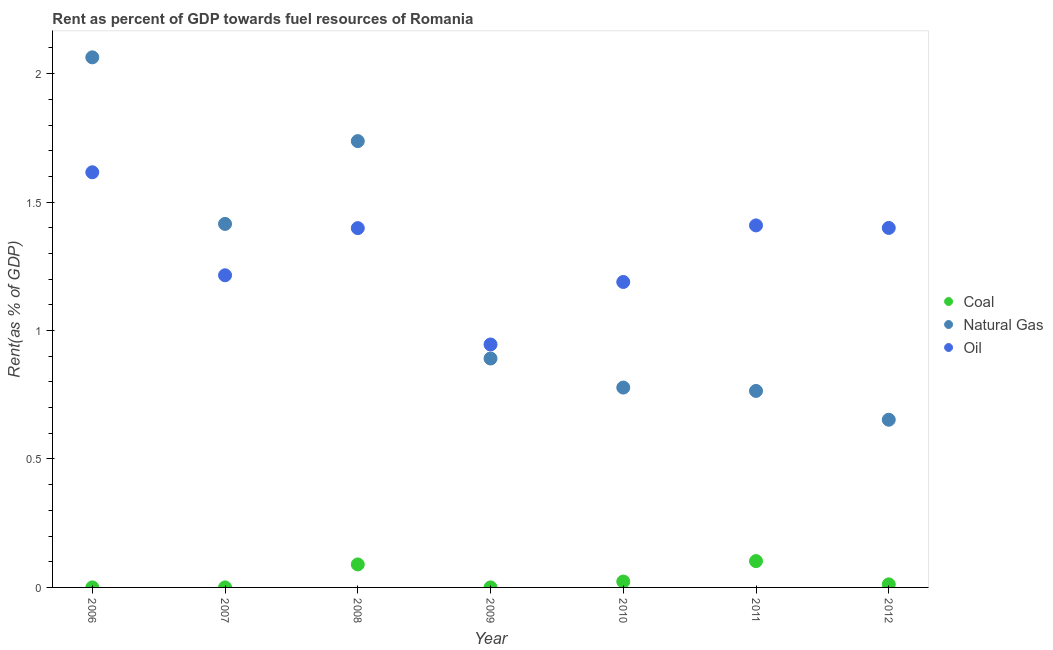How many different coloured dotlines are there?
Make the answer very short. 3. Is the number of dotlines equal to the number of legend labels?
Provide a succinct answer. Yes. What is the rent towards natural gas in 2011?
Provide a succinct answer. 0.76. Across all years, what is the maximum rent towards coal?
Your response must be concise. 0.1. Across all years, what is the minimum rent towards natural gas?
Offer a very short reply. 0.65. In which year was the rent towards oil minimum?
Your response must be concise. 2009. What is the total rent towards coal in the graph?
Your response must be concise. 0.23. What is the difference between the rent towards natural gas in 2008 and that in 2010?
Provide a succinct answer. 0.96. What is the difference between the rent towards natural gas in 2007 and the rent towards coal in 2006?
Keep it short and to the point. 1.41. What is the average rent towards oil per year?
Your answer should be compact. 1.31. In the year 2012, what is the difference between the rent towards coal and rent towards natural gas?
Offer a terse response. -0.64. In how many years, is the rent towards natural gas greater than 1.4 %?
Your response must be concise. 3. What is the ratio of the rent towards oil in 2010 to that in 2011?
Provide a short and direct response. 0.84. What is the difference between the highest and the second highest rent towards natural gas?
Your answer should be very brief. 0.33. What is the difference between the highest and the lowest rent towards oil?
Offer a terse response. 0.67. Is it the case that in every year, the sum of the rent towards coal and rent towards natural gas is greater than the rent towards oil?
Your answer should be very brief. No. Does the rent towards coal monotonically increase over the years?
Provide a short and direct response. No. Is the rent towards oil strictly greater than the rent towards coal over the years?
Keep it short and to the point. Yes. Where does the legend appear in the graph?
Provide a succinct answer. Center right. How many legend labels are there?
Your answer should be very brief. 3. What is the title of the graph?
Offer a terse response. Rent as percent of GDP towards fuel resources of Romania. What is the label or title of the X-axis?
Give a very brief answer. Year. What is the label or title of the Y-axis?
Give a very brief answer. Rent(as % of GDP). What is the Rent(as % of GDP) of Coal in 2006?
Give a very brief answer. 7.42123758365009e-5. What is the Rent(as % of GDP) of Natural Gas in 2006?
Your answer should be compact. 2.06. What is the Rent(as % of GDP) in Oil in 2006?
Keep it short and to the point. 1.62. What is the Rent(as % of GDP) in Coal in 2007?
Offer a terse response. 9.89979329873995e-5. What is the Rent(as % of GDP) of Natural Gas in 2007?
Give a very brief answer. 1.42. What is the Rent(as % of GDP) of Oil in 2007?
Offer a terse response. 1.22. What is the Rent(as % of GDP) in Coal in 2008?
Give a very brief answer. 0.09. What is the Rent(as % of GDP) of Natural Gas in 2008?
Your answer should be compact. 1.74. What is the Rent(as % of GDP) of Oil in 2008?
Offer a very short reply. 1.4. What is the Rent(as % of GDP) in Coal in 2009?
Offer a very short reply. 9.91154234092374e-5. What is the Rent(as % of GDP) in Natural Gas in 2009?
Offer a very short reply. 0.89. What is the Rent(as % of GDP) in Oil in 2009?
Ensure brevity in your answer.  0.95. What is the Rent(as % of GDP) in Coal in 2010?
Ensure brevity in your answer.  0.02. What is the Rent(as % of GDP) in Natural Gas in 2010?
Your answer should be very brief. 0.78. What is the Rent(as % of GDP) of Oil in 2010?
Offer a terse response. 1.19. What is the Rent(as % of GDP) in Coal in 2011?
Offer a very short reply. 0.1. What is the Rent(as % of GDP) of Natural Gas in 2011?
Ensure brevity in your answer.  0.76. What is the Rent(as % of GDP) in Oil in 2011?
Provide a succinct answer. 1.41. What is the Rent(as % of GDP) in Coal in 2012?
Your answer should be very brief. 0.01. What is the Rent(as % of GDP) of Natural Gas in 2012?
Keep it short and to the point. 0.65. What is the Rent(as % of GDP) of Oil in 2012?
Offer a terse response. 1.4. Across all years, what is the maximum Rent(as % of GDP) of Coal?
Provide a succinct answer. 0.1. Across all years, what is the maximum Rent(as % of GDP) of Natural Gas?
Provide a short and direct response. 2.06. Across all years, what is the maximum Rent(as % of GDP) in Oil?
Your response must be concise. 1.62. Across all years, what is the minimum Rent(as % of GDP) in Coal?
Your answer should be compact. 7.42123758365009e-5. Across all years, what is the minimum Rent(as % of GDP) in Natural Gas?
Give a very brief answer. 0.65. Across all years, what is the minimum Rent(as % of GDP) in Oil?
Ensure brevity in your answer.  0.95. What is the total Rent(as % of GDP) of Coal in the graph?
Ensure brevity in your answer.  0.23. What is the total Rent(as % of GDP) of Natural Gas in the graph?
Ensure brevity in your answer.  8.3. What is the total Rent(as % of GDP) in Oil in the graph?
Keep it short and to the point. 9.17. What is the difference between the Rent(as % of GDP) of Coal in 2006 and that in 2007?
Ensure brevity in your answer.  -0. What is the difference between the Rent(as % of GDP) of Natural Gas in 2006 and that in 2007?
Your response must be concise. 0.65. What is the difference between the Rent(as % of GDP) of Oil in 2006 and that in 2007?
Make the answer very short. 0.4. What is the difference between the Rent(as % of GDP) in Coal in 2006 and that in 2008?
Ensure brevity in your answer.  -0.09. What is the difference between the Rent(as % of GDP) of Natural Gas in 2006 and that in 2008?
Offer a very short reply. 0.33. What is the difference between the Rent(as % of GDP) of Oil in 2006 and that in 2008?
Your response must be concise. 0.22. What is the difference between the Rent(as % of GDP) of Natural Gas in 2006 and that in 2009?
Make the answer very short. 1.17. What is the difference between the Rent(as % of GDP) in Oil in 2006 and that in 2009?
Your answer should be very brief. 0.67. What is the difference between the Rent(as % of GDP) in Coal in 2006 and that in 2010?
Keep it short and to the point. -0.02. What is the difference between the Rent(as % of GDP) in Natural Gas in 2006 and that in 2010?
Your response must be concise. 1.29. What is the difference between the Rent(as % of GDP) in Oil in 2006 and that in 2010?
Give a very brief answer. 0.43. What is the difference between the Rent(as % of GDP) of Coal in 2006 and that in 2011?
Your response must be concise. -0.1. What is the difference between the Rent(as % of GDP) in Natural Gas in 2006 and that in 2011?
Provide a short and direct response. 1.3. What is the difference between the Rent(as % of GDP) of Oil in 2006 and that in 2011?
Make the answer very short. 0.21. What is the difference between the Rent(as % of GDP) of Coal in 2006 and that in 2012?
Provide a short and direct response. -0.01. What is the difference between the Rent(as % of GDP) of Natural Gas in 2006 and that in 2012?
Provide a short and direct response. 1.41. What is the difference between the Rent(as % of GDP) in Oil in 2006 and that in 2012?
Give a very brief answer. 0.22. What is the difference between the Rent(as % of GDP) of Coal in 2007 and that in 2008?
Offer a very short reply. -0.09. What is the difference between the Rent(as % of GDP) in Natural Gas in 2007 and that in 2008?
Your answer should be compact. -0.32. What is the difference between the Rent(as % of GDP) of Oil in 2007 and that in 2008?
Your answer should be very brief. -0.18. What is the difference between the Rent(as % of GDP) of Coal in 2007 and that in 2009?
Make the answer very short. -0. What is the difference between the Rent(as % of GDP) of Natural Gas in 2007 and that in 2009?
Ensure brevity in your answer.  0.52. What is the difference between the Rent(as % of GDP) of Oil in 2007 and that in 2009?
Make the answer very short. 0.27. What is the difference between the Rent(as % of GDP) in Coal in 2007 and that in 2010?
Keep it short and to the point. -0.02. What is the difference between the Rent(as % of GDP) in Natural Gas in 2007 and that in 2010?
Offer a terse response. 0.64. What is the difference between the Rent(as % of GDP) in Oil in 2007 and that in 2010?
Make the answer very short. 0.03. What is the difference between the Rent(as % of GDP) of Coal in 2007 and that in 2011?
Provide a short and direct response. -0.1. What is the difference between the Rent(as % of GDP) of Natural Gas in 2007 and that in 2011?
Provide a short and direct response. 0.65. What is the difference between the Rent(as % of GDP) in Oil in 2007 and that in 2011?
Give a very brief answer. -0.19. What is the difference between the Rent(as % of GDP) in Coal in 2007 and that in 2012?
Your answer should be very brief. -0.01. What is the difference between the Rent(as % of GDP) of Natural Gas in 2007 and that in 2012?
Keep it short and to the point. 0.76. What is the difference between the Rent(as % of GDP) of Oil in 2007 and that in 2012?
Ensure brevity in your answer.  -0.18. What is the difference between the Rent(as % of GDP) in Coal in 2008 and that in 2009?
Your response must be concise. 0.09. What is the difference between the Rent(as % of GDP) in Natural Gas in 2008 and that in 2009?
Your answer should be compact. 0.85. What is the difference between the Rent(as % of GDP) of Oil in 2008 and that in 2009?
Offer a terse response. 0.45. What is the difference between the Rent(as % of GDP) in Coal in 2008 and that in 2010?
Your answer should be compact. 0.07. What is the difference between the Rent(as % of GDP) in Natural Gas in 2008 and that in 2010?
Provide a succinct answer. 0.96. What is the difference between the Rent(as % of GDP) of Oil in 2008 and that in 2010?
Your answer should be very brief. 0.21. What is the difference between the Rent(as % of GDP) in Coal in 2008 and that in 2011?
Your answer should be very brief. -0.01. What is the difference between the Rent(as % of GDP) in Natural Gas in 2008 and that in 2011?
Provide a succinct answer. 0.97. What is the difference between the Rent(as % of GDP) in Oil in 2008 and that in 2011?
Offer a terse response. -0.01. What is the difference between the Rent(as % of GDP) of Coal in 2008 and that in 2012?
Provide a short and direct response. 0.08. What is the difference between the Rent(as % of GDP) in Natural Gas in 2008 and that in 2012?
Provide a succinct answer. 1.08. What is the difference between the Rent(as % of GDP) in Oil in 2008 and that in 2012?
Offer a very short reply. -0. What is the difference between the Rent(as % of GDP) of Coal in 2009 and that in 2010?
Provide a succinct answer. -0.02. What is the difference between the Rent(as % of GDP) in Natural Gas in 2009 and that in 2010?
Keep it short and to the point. 0.11. What is the difference between the Rent(as % of GDP) in Oil in 2009 and that in 2010?
Ensure brevity in your answer.  -0.24. What is the difference between the Rent(as % of GDP) in Coal in 2009 and that in 2011?
Your answer should be very brief. -0.1. What is the difference between the Rent(as % of GDP) in Natural Gas in 2009 and that in 2011?
Ensure brevity in your answer.  0.13. What is the difference between the Rent(as % of GDP) of Oil in 2009 and that in 2011?
Ensure brevity in your answer.  -0.46. What is the difference between the Rent(as % of GDP) of Coal in 2009 and that in 2012?
Your answer should be very brief. -0.01. What is the difference between the Rent(as % of GDP) of Natural Gas in 2009 and that in 2012?
Ensure brevity in your answer.  0.24. What is the difference between the Rent(as % of GDP) in Oil in 2009 and that in 2012?
Offer a terse response. -0.45. What is the difference between the Rent(as % of GDP) in Coal in 2010 and that in 2011?
Your response must be concise. -0.08. What is the difference between the Rent(as % of GDP) in Natural Gas in 2010 and that in 2011?
Your answer should be very brief. 0.01. What is the difference between the Rent(as % of GDP) of Oil in 2010 and that in 2011?
Give a very brief answer. -0.22. What is the difference between the Rent(as % of GDP) of Coal in 2010 and that in 2012?
Offer a terse response. 0.01. What is the difference between the Rent(as % of GDP) of Natural Gas in 2010 and that in 2012?
Make the answer very short. 0.13. What is the difference between the Rent(as % of GDP) of Oil in 2010 and that in 2012?
Provide a short and direct response. -0.21. What is the difference between the Rent(as % of GDP) of Coal in 2011 and that in 2012?
Offer a very short reply. 0.09. What is the difference between the Rent(as % of GDP) in Natural Gas in 2011 and that in 2012?
Provide a short and direct response. 0.11. What is the difference between the Rent(as % of GDP) of Oil in 2011 and that in 2012?
Keep it short and to the point. 0.01. What is the difference between the Rent(as % of GDP) in Coal in 2006 and the Rent(as % of GDP) in Natural Gas in 2007?
Make the answer very short. -1.42. What is the difference between the Rent(as % of GDP) in Coal in 2006 and the Rent(as % of GDP) in Oil in 2007?
Ensure brevity in your answer.  -1.22. What is the difference between the Rent(as % of GDP) in Natural Gas in 2006 and the Rent(as % of GDP) in Oil in 2007?
Your answer should be compact. 0.85. What is the difference between the Rent(as % of GDP) of Coal in 2006 and the Rent(as % of GDP) of Natural Gas in 2008?
Your response must be concise. -1.74. What is the difference between the Rent(as % of GDP) of Coal in 2006 and the Rent(as % of GDP) of Oil in 2008?
Make the answer very short. -1.4. What is the difference between the Rent(as % of GDP) in Natural Gas in 2006 and the Rent(as % of GDP) in Oil in 2008?
Offer a terse response. 0.66. What is the difference between the Rent(as % of GDP) in Coal in 2006 and the Rent(as % of GDP) in Natural Gas in 2009?
Give a very brief answer. -0.89. What is the difference between the Rent(as % of GDP) of Coal in 2006 and the Rent(as % of GDP) of Oil in 2009?
Your answer should be compact. -0.95. What is the difference between the Rent(as % of GDP) of Natural Gas in 2006 and the Rent(as % of GDP) of Oil in 2009?
Make the answer very short. 1.12. What is the difference between the Rent(as % of GDP) of Coal in 2006 and the Rent(as % of GDP) of Natural Gas in 2010?
Keep it short and to the point. -0.78. What is the difference between the Rent(as % of GDP) of Coal in 2006 and the Rent(as % of GDP) of Oil in 2010?
Your answer should be compact. -1.19. What is the difference between the Rent(as % of GDP) of Natural Gas in 2006 and the Rent(as % of GDP) of Oil in 2010?
Offer a very short reply. 0.87. What is the difference between the Rent(as % of GDP) in Coal in 2006 and the Rent(as % of GDP) in Natural Gas in 2011?
Ensure brevity in your answer.  -0.76. What is the difference between the Rent(as % of GDP) in Coal in 2006 and the Rent(as % of GDP) in Oil in 2011?
Keep it short and to the point. -1.41. What is the difference between the Rent(as % of GDP) of Natural Gas in 2006 and the Rent(as % of GDP) of Oil in 2011?
Your answer should be very brief. 0.65. What is the difference between the Rent(as % of GDP) in Coal in 2006 and the Rent(as % of GDP) in Natural Gas in 2012?
Provide a succinct answer. -0.65. What is the difference between the Rent(as % of GDP) in Coal in 2006 and the Rent(as % of GDP) in Oil in 2012?
Make the answer very short. -1.4. What is the difference between the Rent(as % of GDP) of Natural Gas in 2006 and the Rent(as % of GDP) of Oil in 2012?
Provide a succinct answer. 0.66. What is the difference between the Rent(as % of GDP) in Coal in 2007 and the Rent(as % of GDP) in Natural Gas in 2008?
Your answer should be compact. -1.74. What is the difference between the Rent(as % of GDP) in Coal in 2007 and the Rent(as % of GDP) in Oil in 2008?
Provide a succinct answer. -1.4. What is the difference between the Rent(as % of GDP) in Natural Gas in 2007 and the Rent(as % of GDP) in Oil in 2008?
Provide a succinct answer. 0.02. What is the difference between the Rent(as % of GDP) in Coal in 2007 and the Rent(as % of GDP) in Natural Gas in 2009?
Give a very brief answer. -0.89. What is the difference between the Rent(as % of GDP) in Coal in 2007 and the Rent(as % of GDP) in Oil in 2009?
Give a very brief answer. -0.95. What is the difference between the Rent(as % of GDP) of Natural Gas in 2007 and the Rent(as % of GDP) of Oil in 2009?
Provide a short and direct response. 0.47. What is the difference between the Rent(as % of GDP) in Coal in 2007 and the Rent(as % of GDP) in Natural Gas in 2010?
Your answer should be compact. -0.78. What is the difference between the Rent(as % of GDP) in Coal in 2007 and the Rent(as % of GDP) in Oil in 2010?
Keep it short and to the point. -1.19. What is the difference between the Rent(as % of GDP) in Natural Gas in 2007 and the Rent(as % of GDP) in Oil in 2010?
Your answer should be very brief. 0.23. What is the difference between the Rent(as % of GDP) in Coal in 2007 and the Rent(as % of GDP) in Natural Gas in 2011?
Provide a succinct answer. -0.76. What is the difference between the Rent(as % of GDP) in Coal in 2007 and the Rent(as % of GDP) in Oil in 2011?
Your response must be concise. -1.41. What is the difference between the Rent(as % of GDP) in Natural Gas in 2007 and the Rent(as % of GDP) in Oil in 2011?
Give a very brief answer. 0.01. What is the difference between the Rent(as % of GDP) in Coal in 2007 and the Rent(as % of GDP) in Natural Gas in 2012?
Your answer should be very brief. -0.65. What is the difference between the Rent(as % of GDP) of Coal in 2007 and the Rent(as % of GDP) of Oil in 2012?
Keep it short and to the point. -1.4. What is the difference between the Rent(as % of GDP) in Natural Gas in 2007 and the Rent(as % of GDP) in Oil in 2012?
Your response must be concise. 0.02. What is the difference between the Rent(as % of GDP) in Coal in 2008 and the Rent(as % of GDP) in Natural Gas in 2009?
Your response must be concise. -0.8. What is the difference between the Rent(as % of GDP) in Coal in 2008 and the Rent(as % of GDP) in Oil in 2009?
Offer a very short reply. -0.86. What is the difference between the Rent(as % of GDP) in Natural Gas in 2008 and the Rent(as % of GDP) in Oil in 2009?
Your response must be concise. 0.79. What is the difference between the Rent(as % of GDP) of Coal in 2008 and the Rent(as % of GDP) of Natural Gas in 2010?
Make the answer very short. -0.69. What is the difference between the Rent(as % of GDP) of Coal in 2008 and the Rent(as % of GDP) of Oil in 2010?
Make the answer very short. -1.1. What is the difference between the Rent(as % of GDP) of Natural Gas in 2008 and the Rent(as % of GDP) of Oil in 2010?
Your answer should be compact. 0.55. What is the difference between the Rent(as % of GDP) in Coal in 2008 and the Rent(as % of GDP) in Natural Gas in 2011?
Provide a short and direct response. -0.68. What is the difference between the Rent(as % of GDP) of Coal in 2008 and the Rent(as % of GDP) of Oil in 2011?
Offer a terse response. -1.32. What is the difference between the Rent(as % of GDP) in Natural Gas in 2008 and the Rent(as % of GDP) in Oil in 2011?
Provide a short and direct response. 0.33. What is the difference between the Rent(as % of GDP) in Coal in 2008 and the Rent(as % of GDP) in Natural Gas in 2012?
Offer a very short reply. -0.56. What is the difference between the Rent(as % of GDP) in Coal in 2008 and the Rent(as % of GDP) in Oil in 2012?
Offer a terse response. -1.31. What is the difference between the Rent(as % of GDP) in Natural Gas in 2008 and the Rent(as % of GDP) in Oil in 2012?
Ensure brevity in your answer.  0.34. What is the difference between the Rent(as % of GDP) of Coal in 2009 and the Rent(as % of GDP) of Natural Gas in 2010?
Keep it short and to the point. -0.78. What is the difference between the Rent(as % of GDP) of Coal in 2009 and the Rent(as % of GDP) of Oil in 2010?
Your response must be concise. -1.19. What is the difference between the Rent(as % of GDP) of Natural Gas in 2009 and the Rent(as % of GDP) of Oil in 2010?
Provide a succinct answer. -0.3. What is the difference between the Rent(as % of GDP) in Coal in 2009 and the Rent(as % of GDP) in Natural Gas in 2011?
Ensure brevity in your answer.  -0.76. What is the difference between the Rent(as % of GDP) of Coal in 2009 and the Rent(as % of GDP) of Oil in 2011?
Make the answer very short. -1.41. What is the difference between the Rent(as % of GDP) of Natural Gas in 2009 and the Rent(as % of GDP) of Oil in 2011?
Your answer should be very brief. -0.52. What is the difference between the Rent(as % of GDP) in Coal in 2009 and the Rent(as % of GDP) in Natural Gas in 2012?
Your answer should be very brief. -0.65. What is the difference between the Rent(as % of GDP) in Coal in 2009 and the Rent(as % of GDP) in Oil in 2012?
Your answer should be compact. -1.4. What is the difference between the Rent(as % of GDP) in Natural Gas in 2009 and the Rent(as % of GDP) in Oil in 2012?
Keep it short and to the point. -0.51. What is the difference between the Rent(as % of GDP) of Coal in 2010 and the Rent(as % of GDP) of Natural Gas in 2011?
Provide a succinct answer. -0.74. What is the difference between the Rent(as % of GDP) of Coal in 2010 and the Rent(as % of GDP) of Oil in 2011?
Your answer should be compact. -1.39. What is the difference between the Rent(as % of GDP) in Natural Gas in 2010 and the Rent(as % of GDP) in Oil in 2011?
Your answer should be very brief. -0.63. What is the difference between the Rent(as % of GDP) of Coal in 2010 and the Rent(as % of GDP) of Natural Gas in 2012?
Provide a succinct answer. -0.63. What is the difference between the Rent(as % of GDP) in Coal in 2010 and the Rent(as % of GDP) in Oil in 2012?
Your answer should be compact. -1.38. What is the difference between the Rent(as % of GDP) of Natural Gas in 2010 and the Rent(as % of GDP) of Oil in 2012?
Keep it short and to the point. -0.62. What is the difference between the Rent(as % of GDP) in Coal in 2011 and the Rent(as % of GDP) in Natural Gas in 2012?
Ensure brevity in your answer.  -0.55. What is the difference between the Rent(as % of GDP) of Coal in 2011 and the Rent(as % of GDP) of Oil in 2012?
Offer a very short reply. -1.3. What is the difference between the Rent(as % of GDP) of Natural Gas in 2011 and the Rent(as % of GDP) of Oil in 2012?
Offer a terse response. -0.63. What is the average Rent(as % of GDP) in Coal per year?
Your response must be concise. 0.03. What is the average Rent(as % of GDP) in Natural Gas per year?
Provide a short and direct response. 1.19. What is the average Rent(as % of GDP) in Oil per year?
Ensure brevity in your answer.  1.31. In the year 2006, what is the difference between the Rent(as % of GDP) of Coal and Rent(as % of GDP) of Natural Gas?
Provide a succinct answer. -2.06. In the year 2006, what is the difference between the Rent(as % of GDP) in Coal and Rent(as % of GDP) in Oil?
Your response must be concise. -1.62. In the year 2006, what is the difference between the Rent(as % of GDP) in Natural Gas and Rent(as % of GDP) in Oil?
Provide a short and direct response. 0.45. In the year 2007, what is the difference between the Rent(as % of GDP) in Coal and Rent(as % of GDP) in Natural Gas?
Provide a short and direct response. -1.42. In the year 2007, what is the difference between the Rent(as % of GDP) in Coal and Rent(as % of GDP) in Oil?
Your response must be concise. -1.22. In the year 2007, what is the difference between the Rent(as % of GDP) in Natural Gas and Rent(as % of GDP) in Oil?
Offer a very short reply. 0.2. In the year 2008, what is the difference between the Rent(as % of GDP) in Coal and Rent(as % of GDP) in Natural Gas?
Your answer should be very brief. -1.65. In the year 2008, what is the difference between the Rent(as % of GDP) of Coal and Rent(as % of GDP) of Oil?
Ensure brevity in your answer.  -1.31. In the year 2008, what is the difference between the Rent(as % of GDP) of Natural Gas and Rent(as % of GDP) of Oil?
Provide a short and direct response. 0.34. In the year 2009, what is the difference between the Rent(as % of GDP) in Coal and Rent(as % of GDP) in Natural Gas?
Give a very brief answer. -0.89. In the year 2009, what is the difference between the Rent(as % of GDP) of Coal and Rent(as % of GDP) of Oil?
Offer a very short reply. -0.95. In the year 2009, what is the difference between the Rent(as % of GDP) of Natural Gas and Rent(as % of GDP) of Oil?
Your response must be concise. -0.05. In the year 2010, what is the difference between the Rent(as % of GDP) of Coal and Rent(as % of GDP) of Natural Gas?
Ensure brevity in your answer.  -0.76. In the year 2010, what is the difference between the Rent(as % of GDP) of Coal and Rent(as % of GDP) of Oil?
Ensure brevity in your answer.  -1.17. In the year 2010, what is the difference between the Rent(as % of GDP) of Natural Gas and Rent(as % of GDP) of Oil?
Your response must be concise. -0.41. In the year 2011, what is the difference between the Rent(as % of GDP) in Coal and Rent(as % of GDP) in Natural Gas?
Keep it short and to the point. -0.66. In the year 2011, what is the difference between the Rent(as % of GDP) of Coal and Rent(as % of GDP) of Oil?
Make the answer very short. -1.31. In the year 2011, what is the difference between the Rent(as % of GDP) of Natural Gas and Rent(as % of GDP) of Oil?
Ensure brevity in your answer.  -0.64. In the year 2012, what is the difference between the Rent(as % of GDP) in Coal and Rent(as % of GDP) in Natural Gas?
Ensure brevity in your answer.  -0.64. In the year 2012, what is the difference between the Rent(as % of GDP) in Coal and Rent(as % of GDP) in Oil?
Give a very brief answer. -1.39. In the year 2012, what is the difference between the Rent(as % of GDP) in Natural Gas and Rent(as % of GDP) in Oil?
Provide a short and direct response. -0.75. What is the ratio of the Rent(as % of GDP) of Coal in 2006 to that in 2007?
Your answer should be very brief. 0.75. What is the ratio of the Rent(as % of GDP) in Natural Gas in 2006 to that in 2007?
Make the answer very short. 1.46. What is the ratio of the Rent(as % of GDP) in Oil in 2006 to that in 2007?
Give a very brief answer. 1.33. What is the ratio of the Rent(as % of GDP) of Coal in 2006 to that in 2008?
Make the answer very short. 0. What is the ratio of the Rent(as % of GDP) of Natural Gas in 2006 to that in 2008?
Offer a terse response. 1.19. What is the ratio of the Rent(as % of GDP) of Oil in 2006 to that in 2008?
Your answer should be compact. 1.16. What is the ratio of the Rent(as % of GDP) in Coal in 2006 to that in 2009?
Provide a succinct answer. 0.75. What is the ratio of the Rent(as % of GDP) in Natural Gas in 2006 to that in 2009?
Your answer should be very brief. 2.32. What is the ratio of the Rent(as % of GDP) in Oil in 2006 to that in 2009?
Your answer should be very brief. 1.71. What is the ratio of the Rent(as % of GDP) in Coal in 2006 to that in 2010?
Provide a short and direct response. 0. What is the ratio of the Rent(as % of GDP) in Natural Gas in 2006 to that in 2010?
Keep it short and to the point. 2.65. What is the ratio of the Rent(as % of GDP) in Oil in 2006 to that in 2010?
Your response must be concise. 1.36. What is the ratio of the Rent(as % of GDP) in Coal in 2006 to that in 2011?
Ensure brevity in your answer.  0. What is the ratio of the Rent(as % of GDP) in Natural Gas in 2006 to that in 2011?
Provide a short and direct response. 2.7. What is the ratio of the Rent(as % of GDP) in Oil in 2006 to that in 2011?
Your answer should be very brief. 1.15. What is the ratio of the Rent(as % of GDP) in Coal in 2006 to that in 2012?
Your response must be concise. 0.01. What is the ratio of the Rent(as % of GDP) in Natural Gas in 2006 to that in 2012?
Your answer should be compact. 3.16. What is the ratio of the Rent(as % of GDP) of Oil in 2006 to that in 2012?
Provide a succinct answer. 1.15. What is the ratio of the Rent(as % of GDP) in Coal in 2007 to that in 2008?
Your response must be concise. 0. What is the ratio of the Rent(as % of GDP) in Natural Gas in 2007 to that in 2008?
Offer a terse response. 0.81. What is the ratio of the Rent(as % of GDP) of Oil in 2007 to that in 2008?
Your answer should be very brief. 0.87. What is the ratio of the Rent(as % of GDP) in Natural Gas in 2007 to that in 2009?
Keep it short and to the point. 1.59. What is the ratio of the Rent(as % of GDP) in Oil in 2007 to that in 2009?
Give a very brief answer. 1.28. What is the ratio of the Rent(as % of GDP) in Coal in 2007 to that in 2010?
Provide a succinct answer. 0. What is the ratio of the Rent(as % of GDP) in Natural Gas in 2007 to that in 2010?
Your answer should be very brief. 1.82. What is the ratio of the Rent(as % of GDP) of Natural Gas in 2007 to that in 2011?
Your response must be concise. 1.85. What is the ratio of the Rent(as % of GDP) of Oil in 2007 to that in 2011?
Your answer should be very brief. 0.86. What is the ratio of the Rent(as % of GDP) of Coal in 2007 to that in 2012?
Your answer should be compact. 0.01. What is the ratio of the Rent(as % of GDP) of Natural Gas in 2007 to that in 2012?
Offer a terse response. 2.17. What is the ratio of the Rent(as % of GDP) of Oil in 2007 to that in 2012?
Make the answer very short. 0.87. What is the ratio of the Rent(as % of GDP) in Coal in 2008 to that in 2009?
Give a very brief answer. 903.21. What is the ratio of the Rent(as % of GDP) of Natural Gas in 2008 to that in 2009?
Make the answer very short. 1.95. What is the ratio of the Rent(as % of GDP) in Oil in 2008 to that in 2009?
Make the answer very short. 1.48. What is the ratio of the Rent(as % of GDP) of Coal in 2008 to that in 2010?
Keep it short and to the point. 3.91. What is the ratio of the Rent(as % of GDP) of Natural Gas in 2008 to that in 2010?
Provide a succinct answer. 2.23. What is the ratio of the Rent(as % of GDP) in Oil in 2008 to that in 2010?
Your answer should be very brief. 1.18. What is the ratio of the Rent(as % of GDP) of Coal in 2008 to that in 2011?
Offer a terse response. 0.87. What is the ratio of the Rent(as % of GDP) of Natural Gas in 2008 to that in 2011?
Make the answer very short. 2.27. What is the ratio of the Rent(as % of GDP) of Oil in 2008 to that in 2011?
Your answer should be compact. 0.99. What is the ratio of the Rent(as % of GDP) in Coal in 2008 to that in 2012?
Your answer should be compact. 7.51. What is the ratio of the Rent(as % of GDP) of Natural Gas in 2008 to that in 2012?
Offer a very short reply. 2.66. What is the ratio of the Rent(as % of GDP) of Coal in 2009 to that in 2010?
Ensure brevity in your answer.  0. What is the ratio of the Rent(as % of GDP) in Natural Gas in 2009 to that in 2010?
Keep it short and to the point. 1.15. What is the ratio of the Rent(as % of GDP) in Oil in 2009 to that in 2010?
Offer a terse response. 0.8. What is the ratio of the Rent(as % of GDP) in Coal in 2009 to that in 2011?
Make the answer very short. 0. What is the ratio of the Rent(as % of GDP) of Natural Gas in 2009 to that in 2011?
Provide a short and direct response. 1.17. What is the ratio of the Rent(as % of GDP) in Oil in 2009 to that in 2011?
Offer a terse response. 0.67. What is the ratio of the Rent(as % of GDP) in Coal in 2009 to that in 2012?
Ensure brevity in your answer.  0.01. What is the ratio of the Rent(as % of GDP) of Natural Gas in 2009 to that in 2012?
Your answer should be very brief. 1.36. What is the ratio of the Rent(as % of GDP) of Oil in 2009 to that in 2012?
Provide a short and direct response. 0.68. What is the ratio of the Rent(as % of GDP) of Coal in 2010 to that in 2011?
Make the answer very short. 0.22. What is the ratio of the Rent(as % of GDP) in Natural Gas in 2010 to that in 2011?
Offer a very short reply. 1.02. What is the ratio of the Rent(as % of GDP) in Oil in 2010 to that in 2011?
Make the answer very short. 0.84. What is the ratio of the Rent(as % of GDP) in Coal in 2010 to that in 2012?
Provide a short and direct response. 1.92. What is the ratio of the Rent(as % of GDP) of Natural Gas in 2010 to that in 2012?
Ensure brevity in your answer.  1.19. What is the ratio of the Rent(as % of GDP) in Oil in 2010 to that in 2012?
Make the answer very short. 0.85. What is the ratio of the Rent(as % of GDP) of Coal in 2011 to that in 2012?
Your response must be concise. 8.6. What is the ratio of the Rent(as % of GDP) in Natural Gas in 2011 to that in 2012?
Give a very brief answer. 1.17. What is the ratio of the Rent(as % of GDP) in Oil in 2011 to that in 2012?
Your answer should be compact. 1.01. What is the difference between the highest and the second highest Rent(as % of GDP) in Coal?
Ensure brevity in your answer.  0.01. What is the difference between the highest and the second highest Rent(as % of GDP) of Natural Gas?
Your response must be concise. 0.33. What is the difference between the highest and the second highest Rent(as % of GDP) in Oil?
Keep it short and to the point. 0.21. What is the difference between the highest and the lowest Rent(as % of GDP) of Coal?
Make the answer very short. 0.1. What is the difference between the highest and the lowest Rent(as % of GDP) in Natural Gas?
Keep it short and to the point. 1.41. What is the difference between the highest and the lowest Rent(as % of GDP) of Oil?
Your answer should be compact. 0.67. 